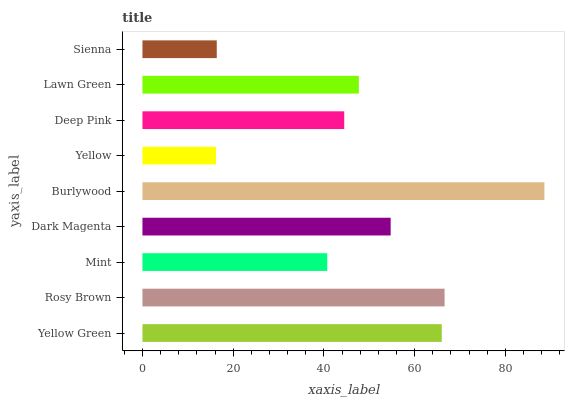Is Yellow the minimum?
Answer yes or no. Yes. Is Burlywood the maximum?
Answer yes or no. Yes. Is Rosy Brown the minimum?
Answer yes or no. No. Is Rosy Brown the maximum?
Answer yes or no. No. Is Rosy Brown greater than Yellow Green?
Answer yes or no. Yes. Is Yellow Green less than Rosy Brown?
Answer yes or no. Yes. Is Yellow Green greater than Rosy Brown?
Answer yes or no. No. Is Rosy Brown less than Yellow Green?
Answer yes or no. No. Is Lawn Green the high median?
Answer yes or no. Yes. Is Lawn Green the low median?
Answer yes or no. Yes. Is Deep Pink the high median?
Answer yes or no. No. Is Yellow the low median?
Answer yes or no. No. 